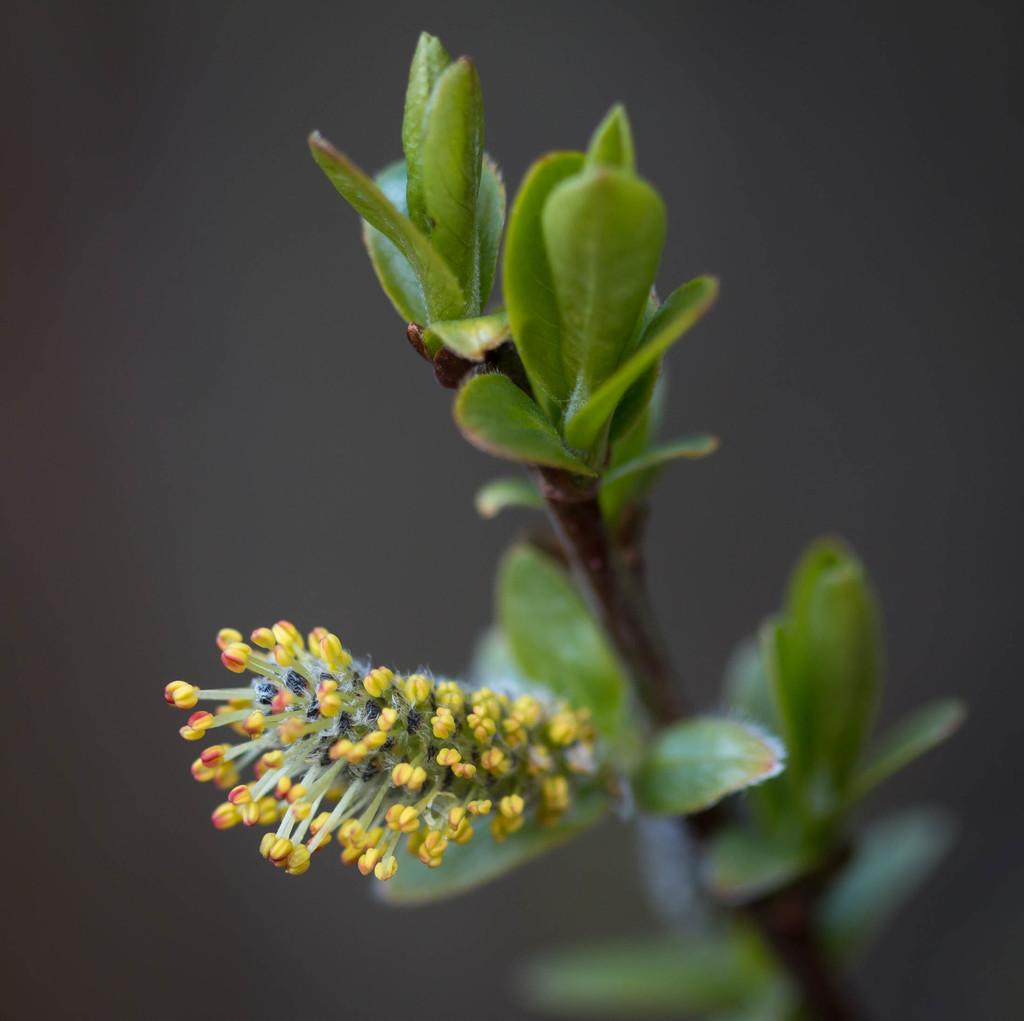What is present on the left side of the image? There are buds on the left side of the image. What color are the buds? The buds are in yellow color. What can be seen on the right side of the image? There are leaves of a plant on the right side of the image. What type of school can be seen in the image? There is no school present in the image; it features buds and leaves of a plant. What company is responsible for producing the can in the image? There is no can present in the image. 